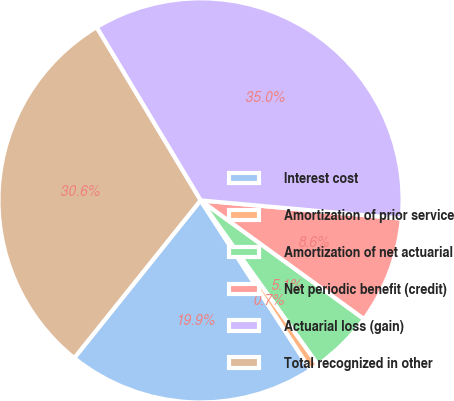Convert chart. <chart><loc_0><loc_0><loc_500><loc_500><pie_chart><fcel>Interest cost<fcel>Amortization of prior service<fcel>Amortization of net actuarial<fcel>Net periodic benefit (credit)<fcel>Actuarial loss (gain)<fcel>Total recognized in other<nl><fcel>19.9%<fcel>0.73%<fcel>5.13%<fcel>8.56%<fcel>35.04%<fcel>30.64%<nl></chart> 